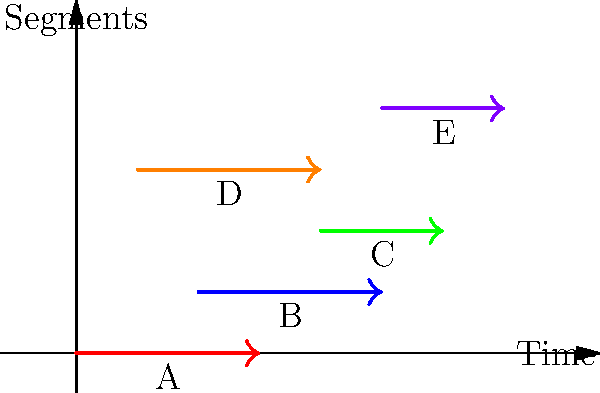As a broadcast journalism major, you're tasked with scheduling interviews for a news segment. The graph shows five interview segments (A, B, C, D, E) represented as intervals on a timeline. What is the minimum number of cameras needed to record all these interviews without conflicts, assuming each camera can only record one interview at a time? To solve this problem, we'll use the concept of interval graphs and graph coloring:

1. Each interval represents an interview segment.
2. Overlapping intervals indicate conflicting time slots.
3. The minimum number of cameras needed is equivalent to the chromatic number of the interval graph.

Let's analyze the conflicts:

1. Segment A conflicts with B and D
2. Segment B conflicts with A, C, and D
3. Segment C conflicts with B and E
4. Segment D conflicts with A and B
5. Segment E conflicts with C

To find the minimum number of cameras, we'll use a greedy coloring algorithm:

1. Sort intervals by start time: A, D, B, C, E
2. Assign colors (cameras) to intervals:
   - A: Camera 1
   - D: Camera 2 (conflicts with A)
   - B: Camera 3 (conflicts with A and D)
   - C: Camera 1 (doesn't conflict with A)
   - E: Camera 2 (doesn't conflict with D)

The algorithm uses 3 colors (cameras), which is the minimum number needed to avoid conflicts.
Answer: 3 cameras 